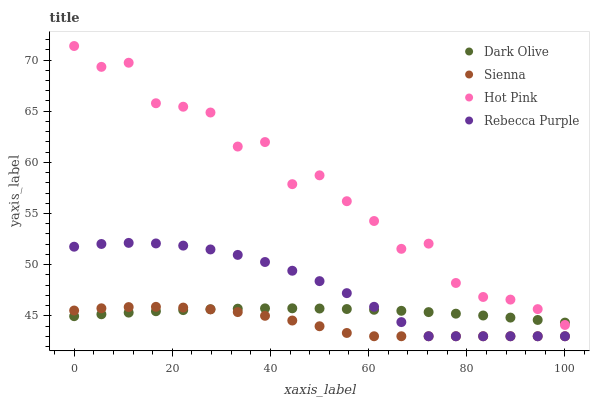Does Sienna have the minimum area under the curve?
Answer yes or no. Yes. Does Hot Pink have the maximum area under the curve?
Answer yes or no. Yes. Does Dark Olive have the minimum area under the curve?
Answer yes or no. No. Does Dark Olive have the maximum area under the curve?
Answer yes or no. No. Is Dark Olive the smoothest?
Answer yes or no. Yes. Is Hot Pink the roughest?
Answer yes or no. Yes. Is Rebecca Purple the smoothest?
Answer yes or no. No. Is Rebecca Purple the roughest?
Answer yes or no. No. Does Sienna have the lowest value?
Answer yes or no. Yes. Does Dark Olive have the lowest value?
Answer yes or no. No. Does Hot Pink have the highest value?
Answer yes or no. Yes. Does Rebecca Purple have the highest value?
Answer yes or no. No. Is Sienna less than Hot Pink?
Answer yes or no. Yes. Is Hot Pink greater than Rebecca Purple?
Answer yes or no. Yes. Does Hot Pink intersect Dark Olive?
Answer yes or no. Yes. Is Hot Pink less than Dark Olive?
Answer yes or no. No. Is Hot Pink greater than Dark Olive?
Answer yes or no. No. Does Sienna intersect Hot Pink?
Answer yes or no. No. 